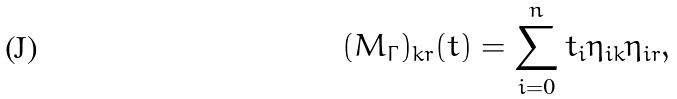<formula> <loc_0><loc_0><loc_500><loc_500>( M _ { \Gamma } ) _ { k r } ( t ) = \sum _ { i = 0 } ^ { n } t _ { i } \eta _ { i k } \eta _ { i r } ,</formula> 